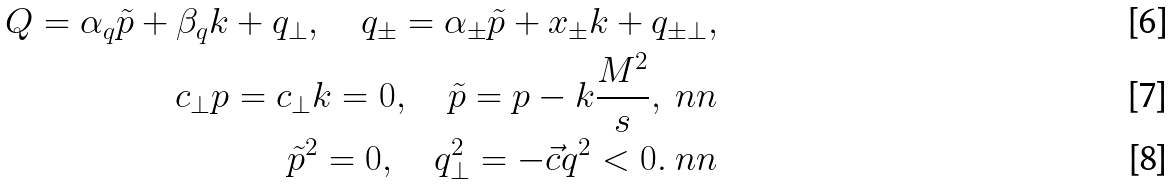<formula> <loc_0><loc_0><loc_500><loc_500>Q = \alpha _ { q } \tilde { p } + \beta _ { q } k + q _ { \bot } , \quad q _ { \pm } = \alpha _ { \pm } \tilde { p } + x _ { \pm } k + q _ { \pm \bot } , \\ c _ { \bot } p = c _ { \bot } k = 0 , \quad \tilde { p } = p - k \frac { M ^ { 2 } } { s } , \ n n \\ \tilde { p } ^ { 2 } = 0 , \quad q _ { \bot } ^ { 2 } = - \vec { c } { q } ^ { 2 } < 0 . \ n n</formula> 